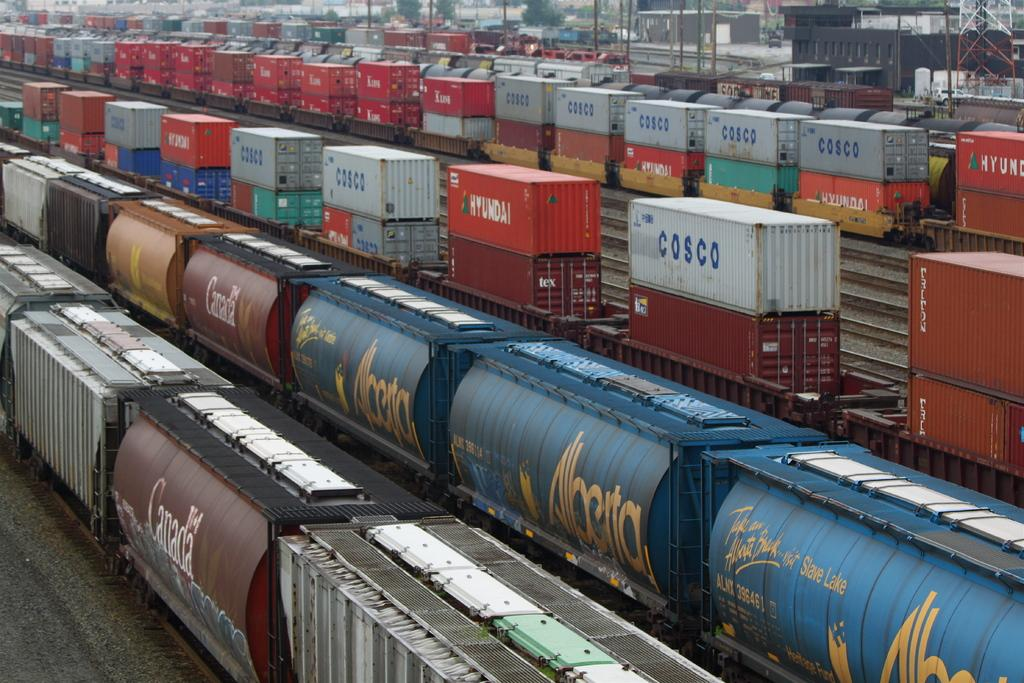<image>
Relay a brief, clear account of the picture shown. the word cosco is on the white item 